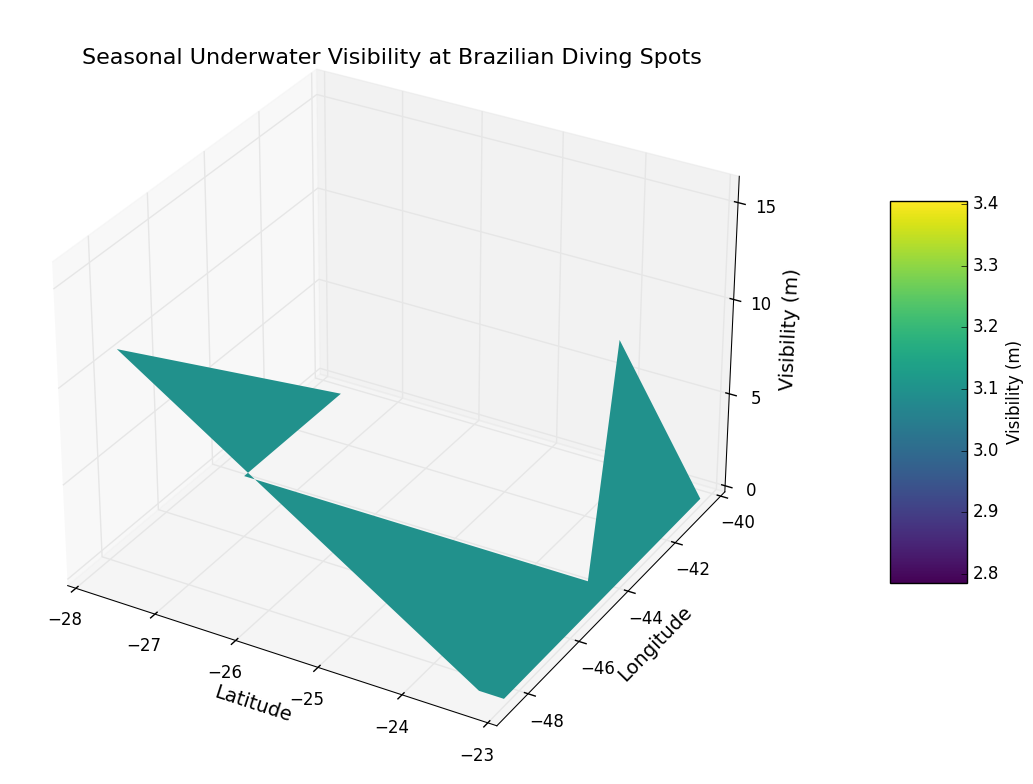What is the location with the lowest average underwater visibility? Locate the lowest points in the 3D surface plot and identify the latitude and longitude of the corresponding location.
Answer: -27.5949, -48.5480 Which location has the highest seasonal visibility variation? Identify the location with the tallest range of heights on the 3D surface plot, indicating a large variation in visibility.
Answer: -23.0104, -44.2689 How does visibility change as you move north to south at the same longitude? Observe the changes in heights along a constant longitude on the 3D plot from north to south latitudes.
Answer: Visibility generally decreases Compare the average visibility of -23.3000, -40.5000 and -27.5949, -48.5480 Identify the heights corresponding to these locations and compute their average. Compare them visually.
Answer: -23.3000, -40.5000 has higher average visibility What is the general trend of underwater visibility between winter and summer seasons? Observe the overall height changes in the 3D plot as months transition from winter to summer.
Answer: Visibility increases during winter and decreases during summer Which latitude exhibits the highest increase in visibility from March to April? Identify all locations along the given latitude and compare the visibility heights between March and April.
Answer: -23.0104 Is there any notable difference in visibility between clear and overcast conditions? Compare visibility heights in regions marked with clear conditions versus overcast conditions across the 3D plot.
Answer: Clear conditions show higher visibility Between latitude -23.0104 and -23.3000, which has more consistent visibility throughout the year? Observe these locations on the 3D plot and determine which one has a relatively flat surface with fewer peaks and valleys.
Answer: -23.3000 Which diving spot is likely to have the best visibility if planning a dive in April? Identify the location and height corresponding to April on the 3D plot.
Answer: -23.3000, -40.5000 Is there any correlation between temperature and visibility based on the 3D plot? Assess if regions within specific temperature ranges also show consistent visibility patterns.
Answer: Higher visibility is generally in cooler temperatures 